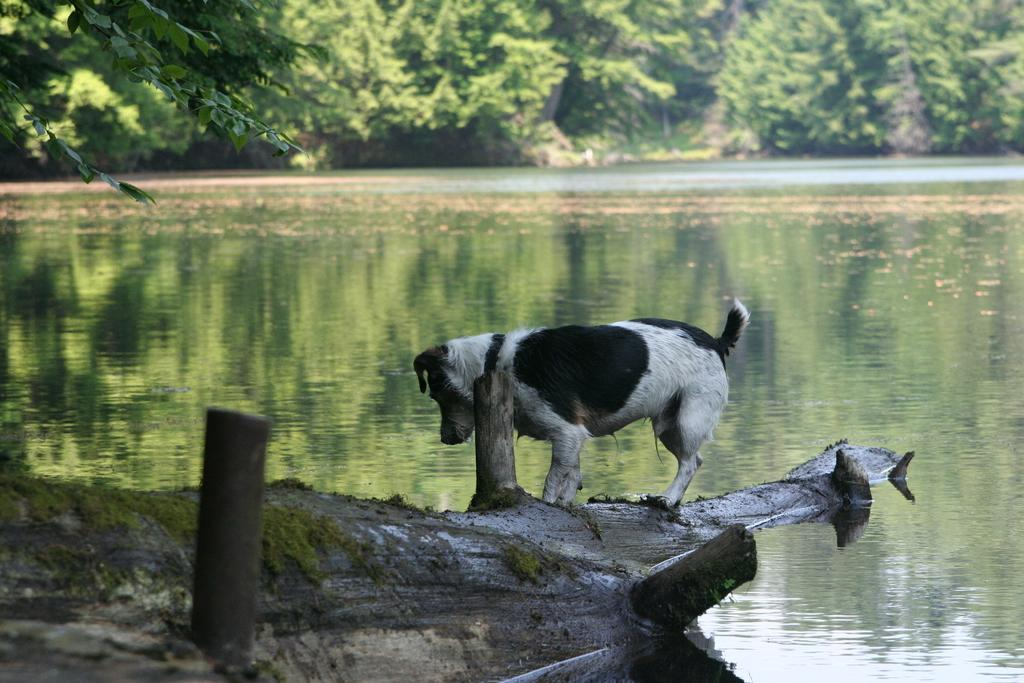What type of body of water is present in the image? There is a lake in the image. the image. What animal can be seen near the lake? There is a dog in front of the lake. What objects are located at the bottom of the image? There are two poles at the bottom of the image. What type of vegetation is visible at the top of the image? There are trees visible at the top of the image. What type of rod can be seen catching fish in the lake? There is no rod or fishing activity depicted in the image. What type of corn is growing near the lake? There is no corn present in the image. 